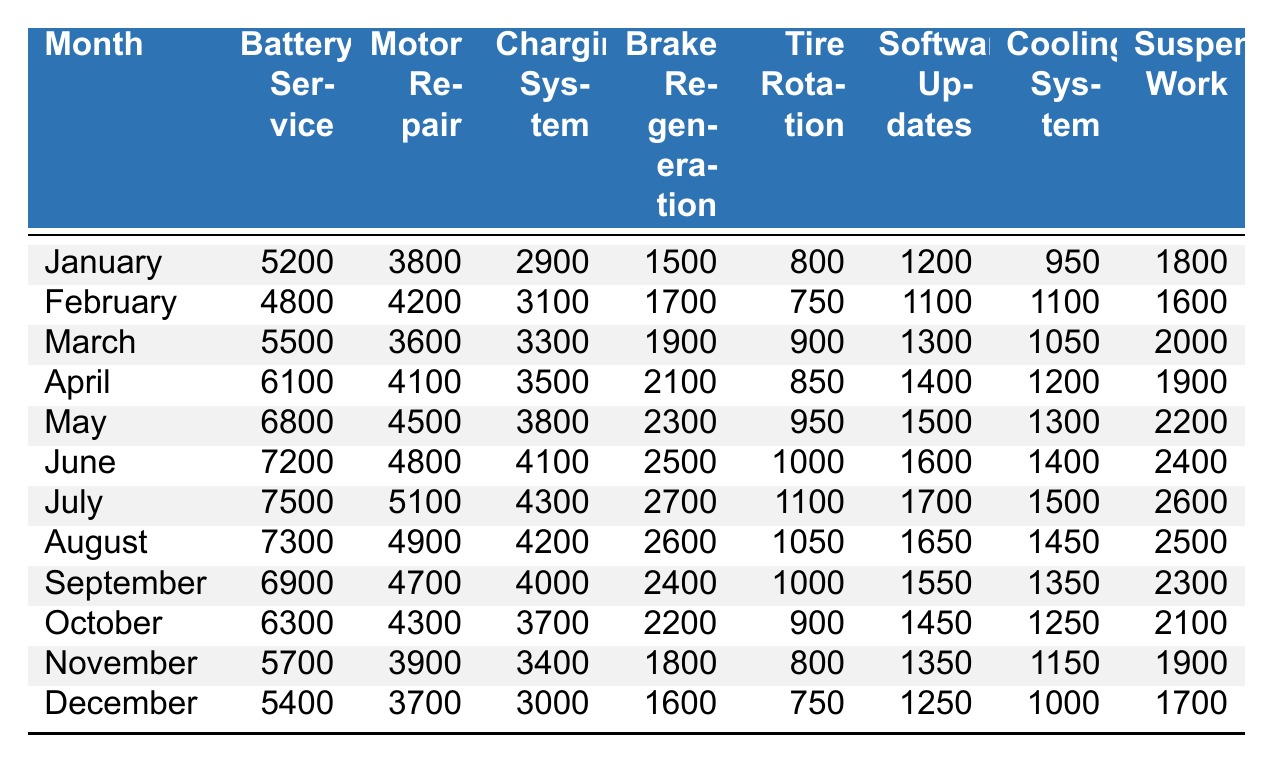What was the revenue from Battery Service in May? In May, the table indicates that the revenue for Battery Service is 6800.
Answer: 6800 What is the total revenue for Suspension Work for the entire year? To find the total revenue for Suspension Work, we sum the amounts for each month: 1800 + 1600 + 2000 + 1900 + 2200 + 2400 + 2600 + 2500 + 2300 + 2100 + 1900 + 1700 = 25000.
Answer: 25000 Which month had the highest revenue from Cooling System? By inspecting each month's Cooling System revenue, July has the highest revenue of 1500.
Answer: July Is the revenue from Software Updates higher in April than in October? In April, the revenue from Software Updates is 1400, while in October it is 1450. Since 1400 is less than 1450, the statement is false.
Answer: No What is the average revenue from Tire Rotation over the year? The Tire Rotation amounts over the year are 800, 750, 900, 850, 950, 1000, 1100, 1050, 1000, 900, 800, 750. The total is 11,800, and the average is 11,800 divided by 12, which is 983.33.
Answer: 983.33 Which service generated the least revenue in December? Looking at December, the least revenue is from Tire Rotation, which is 750.
Answer: Tire Rotation What is the difference in revenue from Motor Repair between January and March? In January, the revenue from Motor Repair is 3800, and in March it is 3600. The difference is 3800 - 3600 = 200.
Answer: 200 Over which months did the revenue from Charging System exceed 3000? By checking each month, the revenue from Charging System is more than 3000 in January, February, March, April, May, June, July, August, September, and October, which totals 10 months.
Answer: 10 months Did the revenue from Brake Regeneration ever fall below 1500? A review of the data shows that every month's revenue from Brake Regeneration is above 1500. Therefore, the statement is false.
Answer: No Which month's revenue was closest to the annual average from Battery Service? The annual total for Battery Service is 68000, so the average is 68000/12 = 5666.67. The month closest to this average is September with a revenue of 6900, which is the least deviation.
Answer: September 